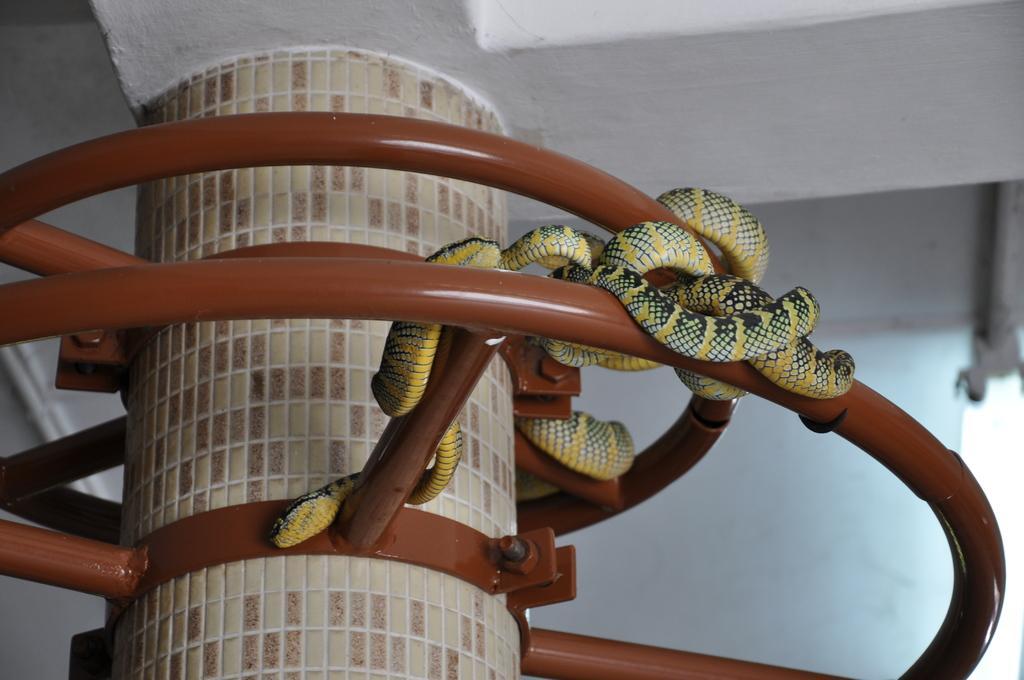Could you give a brief overview of what you see in this image? In the picture I can see the pillar of a building. I can see the metal structure block and I can see the snakes on the metal structure block. 